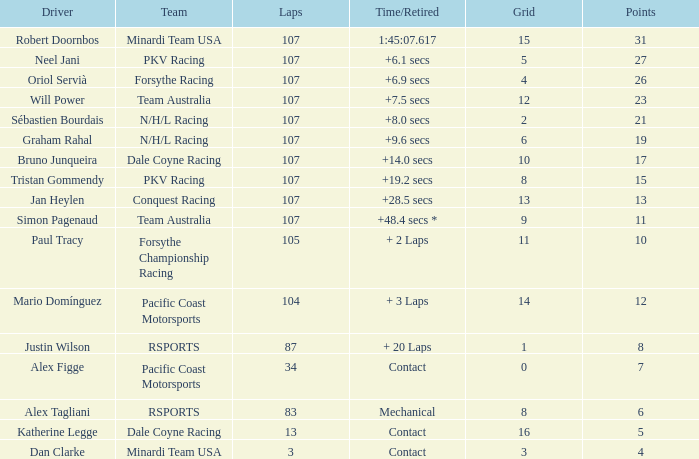What is the highest number of points scored by minardi team usa in more than 13 laps? 31.0. 